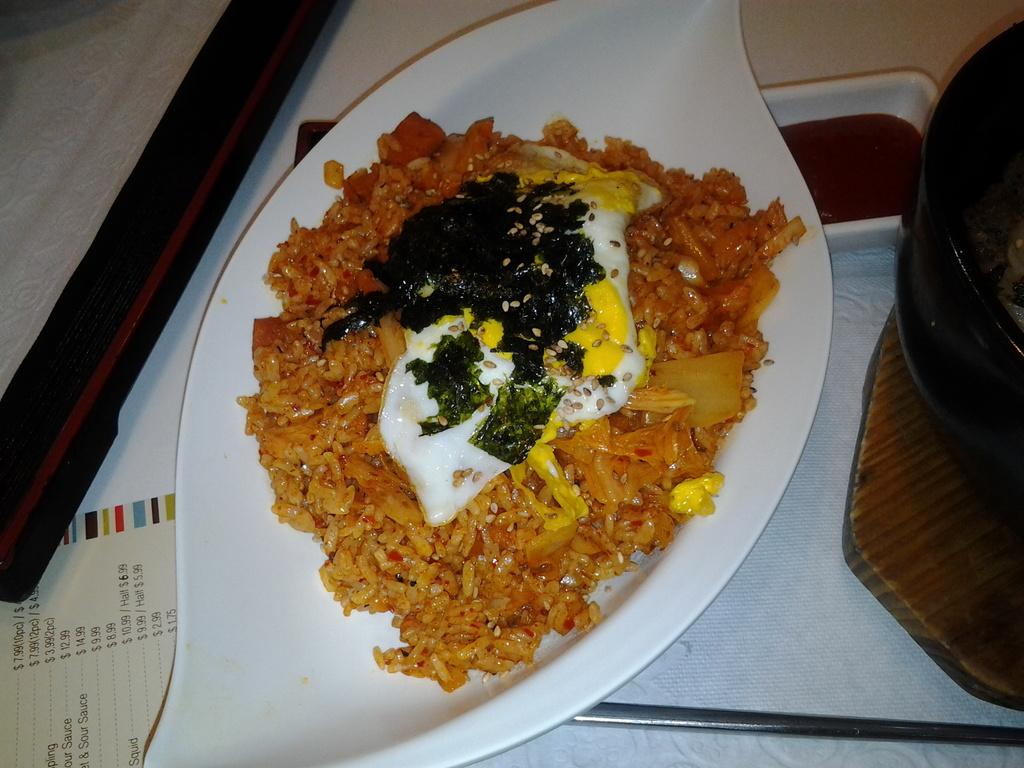What is present on the table in the image? There is a menu card and a tray on the table in the image. What is on the tray? There is a plate with an omelet and another food item on the tray. Is there any other food item visible in the image? Yes, there is a bowl with a food item in the image. How many fingers can be seen pointing at the omelet in the image? There are no fingers visible in the image, as it only shows a table with various food items and a menu card. 